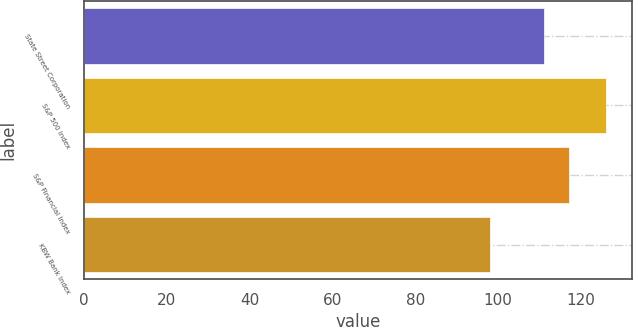<chart> <loc_0><loc_0><loc_500><loc_500><bar_chart><fcel>State Street Corporation<fcel>S&P 500 Index<fcel>S&P Financial Index<fcel>KBW Bank Index<nl><fcel>111<fcel>126<fcel>117<fcel>98<nl></chart> 